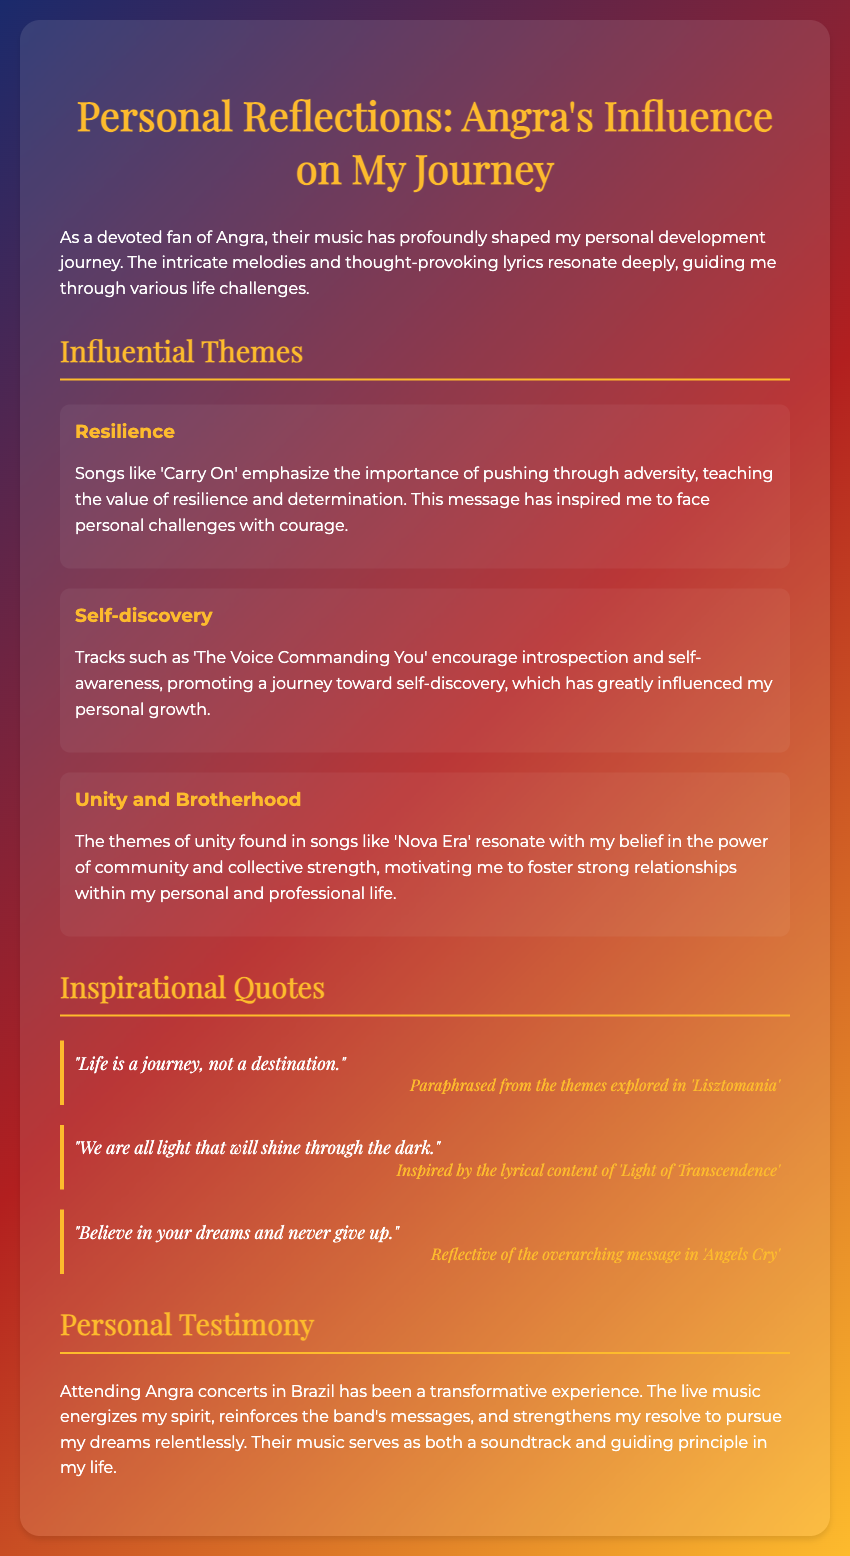What is the title of the document? The title of the document is presented prominently at the top as the heading.
Answer: Personal Reflections: Angra's Influence on My Journey What song is mentioned as emphasizing resilience? The song that emphasizes resilience is listed under the theme of Resilience in the document.
Answer: Carry On Which theme is associated with self-discovery? The theme associated with self-discovery is identified in the section discussing various influential themes.
Answer: Self-discovery How many inspirational quotes are included in the document? The document contains a section explicitly labeled Inspirational Quotes with multiple entries.
Answer: Three What event has been described as a transformative experience? The document mentions attending Angra concerts in Brazil as a transformative experience.
Answer: Angra concerts Which song is linked to the quote about dreams? The song that is reflective of the overarching message about dreams is stated alongside the quote in the document.
Answer: Angels Cry What color is used for the headings in the document? The color used for the headings is mentioned in the styling part of the document.
Answer: #fdbb2d What does the theme of Unity and Brotherhood emphasize? The theme of Unity and Brotherhood focuses on the power of community as detailed in the document.
Answer: Community 